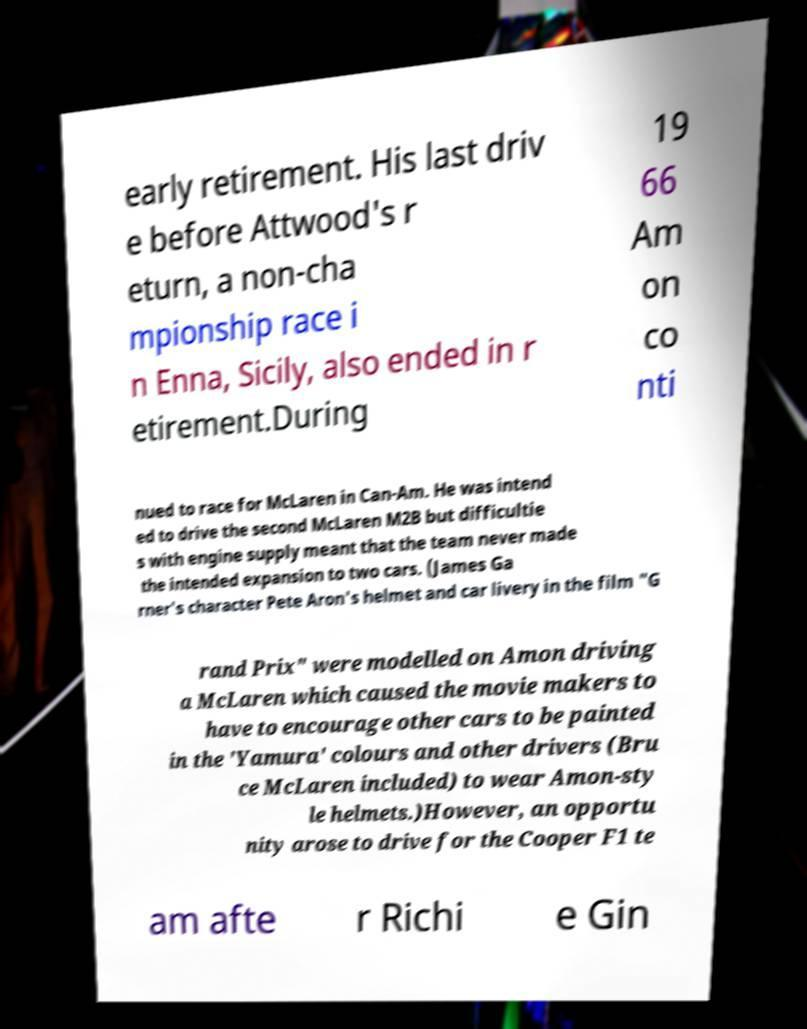Could you assist in decoding the text presented in this image and type it out clearly? early retirement. His last driv e before Attwood's r eturn, a non-cha mpionship race i n Enna, Sicily, also ended in r etirement.During 19 66 Am on co nti nued to race for McLaren in Can-Am. He was intend ed to drive the second McLaren M2B but difficultie s with engine supply meant that the team never made the intended expansion to two cars. (James Ga rner's character Pete Aron's helmet and car livery in the film "G rand Prix" were modelled on Amon driving a McLaren which caused the movie makers to have to encourage other cars to be painted in the 'Yamura' colours and other drivers (Bru ce McLaren included) to wear Amon-sty le helmets.)However, an opportu nity arose to drive for the Cooper F1 te am afte r Richi e Gin 